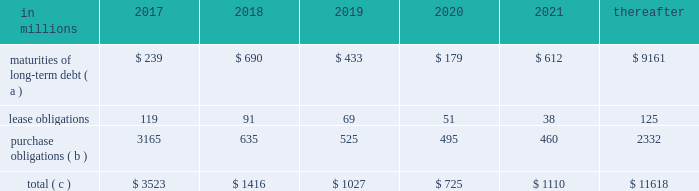Ilim holding s.a .
Shareholder 2019s agreement in october 2007 , in connection with the formation of the ilim holding s.a .
Joint venture , international paper entered into a shareholder 2019s agreement that includes provisions relating to the reconciliation of disputes among the partners .
This agreement provides that at any time , either the company or its partners may commence procedures specified under the deadlock agreement .
If these or any other deadlock procedures under the shareholder's agreement are commenced , although it is not obligated to do so , the company may in certain situations choose to purchase its partners' 50% ( 50 % ) interest in ilim .
Any such transaction would be subject to review and approval by russian and other relevant anti-trust authorities .
Based on the provisions of the agreement , the company estimates that the current purchase price for its partners' 50% ( 50 % ) interests would be approximately $ 1.5 billion , which could be satisfied by payment of cash or international paper common stock , or some combination of the two , at the company's option .
The purchase by the company of its partners 2019 50% ( 50 % ) interest in ilim would result in the consolidation of ilim's financial position and results of operations in all subsequent periods .
The parties have informed each other that they have no current intention to commence procedures specified under the deadlock provisions of the shareholder 2019s agreement .
Critical accounting policies and significant accounting estimates the preparation of financial statements in conformity with accounting principles generally accepted in the united states requires international paper to establish accounting policies and to make estimates that affect both the amounts and timing of the recording of assets , liabilities , revenues and expenses .
Some of these estimates require judgments about matters that are inherently uncertain .
Accounting policies whose application may have a significant effect on the reported results of operations and financial position of international paper , and that can require judgments by management that affect their application , include the accounting for contingencies , impairment or disposal of long-lived assets and goodwill , pensions and postretirement benefit obligations , stock options and income taxes .
The company has discussed the selection of critical accounting policies and the effect of significant estimates with the audit and finance committee of the company 2019s board of directors .
Contingent liabilities accruals for contingent liabilities , including legal and environmental matters , are recorded when it is probable that a liability has been incurred or an asset impaired and the amount of the loss can be reasonably estimated .
Liabilities accrued for legal matters require judgments regarding projected outcomes and range of loss based on historical experience and recommendations of legal counsel .
Liabilities for environmental matters require evaluations of relevant environmental regulations and estimates of future remediation alternatives and costs .
Impairment of long-lived assets and goodwill an impairment of a long-lived asset exists when the asset 2019s carrying amount exceeds its fair value , and is recorded when the carrying amount is not recoverable through cash flows from future operations .
A goodwill impairment exists when the carrying amount of goodwill exceeds its fair value .
Assessments of possible impairments of long-lived assets and goodwill are made when events or changes in circumstances indicate that the carrying value of the asset may not be recoverable through future operations .
Additionally , testing for possible impairment of goodwill and intangible asset balances is required annually .
The amount and timing of any impairment charges based on these assessments require the estimation of future cash flows and the fair market value of the related assets based on management 2019s best estimates of certain key factors , including future selling prices and volumes , operating , raw material , energy and freight costs , and various other projected operating economic factors .
As these key factors change in future periods , the company will update its impairment analyses to reflect its latest estimates and projections .
Under the provisions of accounting standards codification ( asc ) 350 , 201cintangibles 2013 goodwill and other , 201d the testing of goodwill for possible impairment is a two-step process .
In the first step , the fair value of the company 2019s reporting units is compared with their carrying value , including goodwill .
If fair value exceeds the carrying value , goodwill is not considered to be impaired .
If the fair value of a reporting unit is below the carrying value , then step two is performed to measure the amount of the goodwill impairment loss for the reporting unit .
This analysis requires the determination of the fair value of all of the individual assets and liabilities of the reporting unit , including any currently unrecognized intangible assets , as if the reporting unit had been purchased on the analysis date .
Once these fair values have been determined , the implied fair value of the unit 2019s goodwill is calculated as the excess , if any , of the fair value of the reporting unit determined in step one over the fair value of the net assets determined in step two .
The carrying value of goodwill is then reduced to this implied value , or to zero if the fair value of the assets exceeds the fair value of the reporting unit , through a goodwill impairment charge .
The impairment analysis requires a number of judgments by management .
In calculating the estimated fair value of its reporting units in step one , a total debt-to-capital ratio of less than 60% ( 60 % ) .
Net worth is defined as the sum of common stock , paid-in capital and retained earnings , less treasury stock plus any cumulative goodwill impairment charges .
The calculation also excludes accumulated other comprehensive income/loss and nonrecourse financial liabilities of special purpose entities .
The total debt-to-capital ratio is defined as total debt divided by the sum of total debt plus net worth .
The company was in compliance with all its debt covenants at december 31 , 2016 and was well below the thresholds stipulated under the covenants as defined in the credit agreements .
The company will continue to rely upon debt and capital markets for the majority of any necessary long-term funding not provided by operating cash flows .
Funding decisions will be guided by our capital structure planning objectives .
The primary goals of the company 2019s capital structure planning are to maximize financial flexibility and preserve liquidity while reducing interest expense .
The majority of international paper 2019s debt is accessed through global public capital markets where we have a wide base of investors .
Maintaining an investment grade credit rating is an important element of international paper 2019s financing strategy .
At december 31 , 2016 , the company held long-term credit ratings of bbb ( stable outlook ) and baa2 ( stable outlook ) by s&p and moody 2019s , respectively .
Contractual obligations for future payments under existing debt and lease commitments and purchase obligations at december 31 , 2016 , were as follows: .
( a ) total debt includes scheduled principal payments only .
( b ) includes $ 2 billion relating to fiber supply agreements entered into at the time of the 2006 transformation plan forestland sales and in conjunction with the 2008 acquisition of weyerhaeuser company 2019s containerboard , packaging and recycling business .
Also includes $ 1.1 billion relating to fiber supply agreements assumed in conjunction with the 2016 acquisition of weyerhaeuser's pulp business .
( c ) not included in the above table due to the uncertainty as to the amount and timing of the payment are unrecognized tax benefits of approximately $ 77 million .
We consider the undistributed earnings of our foreign subsidiaries as of december 31 , 2016 , to be indefinitely reinvested and , accordingly , no u.s .
Income taxes have been provided thereon .
As of december 31 , 2016 , the amount of cash associated with indefinitely reinvested foreign earnings was approximately $ 620 million .
We do not anticipate the need to repatriate funds to the united states to satisfy domestic liquidity needs arising in the ordinary course of business , including liquidity needs associated with our domestic debt service requirements .
Pension obligations and funding at december 31 , 2016 , the projected benefit obligation for the company 2019s u.s .
Defined benefit plans determined under u.s .
Gaap was approximately $ 3.4 billion higher than the fair value of plan assets .
Approximately $ 3.0 billion of this amount relates to plans that are subject to minimum funding requirements .
Under current irs funding rules , the calculation of minimum funding requirements differs from the calculation of the present value of plan benefits ( the projected benefit obligation ) for accounting purposes .
In december 2008 , the worker , retiree and employer recovery act of 2008 ( wera ) was passed by the u.s .
Congress which provided for pension funding relief and technical corrections .
Funding contributions depend on the funding method selected by the company , and the timing of its implementation , as well as on actual demographic data and the targeted funding level .
The company continually reassesses the amount and timing of any discretionary contributions and elected to make contributions totaling $ 750 million for both years ended december 31 , 2016 and 2015 .
At this time , we do not expect to have any required contributions to our plans in 2017 , although the company may elect to make future voluntary contributions .
The timing and amount of future contributions , which could be material , will depend on a number of factors , including the actual earnings and changes in values of plan assets and changes in interest rates .
International paper announced a voluntary , limited-time opportunity for former employees who are participants in the retirement plan of international paper company ( the pension plan ) to request early payment of their entire pension plan benefit in the form of a single lump sum payment .
The amount of total payments under this program was approximately $ 1.2 billion , and were made from plan trust assets on june 30 , 2016 .
Based on the level of payments made , settlement accounting rules applied and resulted in a plan remeasurement as of the june 30 , 2016 payment date .
As a result of settlement accounting , the company recognized a pro-rata portion of the unamortized net actuarial loss , after remeasurement , resulting in a $ 439 million non-cash charge to the company's earnings in the second quarter of 2016 .
Additional payments of $ 8 million and $ 9 million were made during the third and fourth quarters , respectively , due to mandatory cash payouts and a small lump sum payout , and the pension plan was subsequently remeasured at september 30 , 2016 and december 31 , 2016 .
As a result of settlement accounting , the company recognized non-cash settlement charges of $ 3 million in both the third and fourth quarters of 2016. .
In 2016 what was the percent of the contractual obligations for future payments for purchase obligations due in 2017? 
Computations: (3165 / 3523)
Answer: 0.89838. 